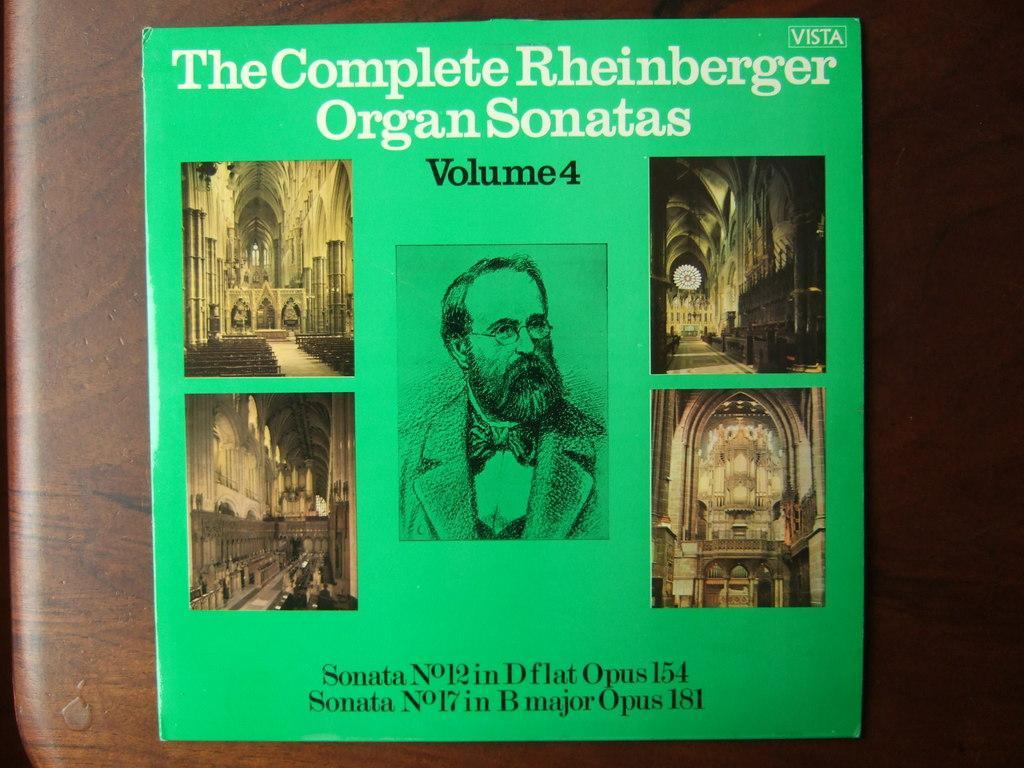Describe this image in one or two sentences. In this image we can see a book placed on the table. 